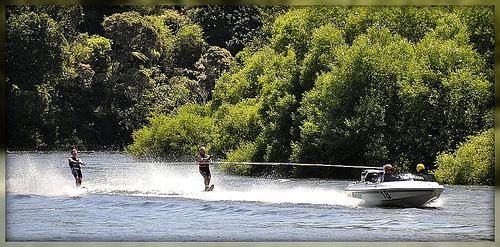What are the two doing behind the boat?

Choices:
A) diving
B) swimming
C) fishing
D) water skiing water skiing 